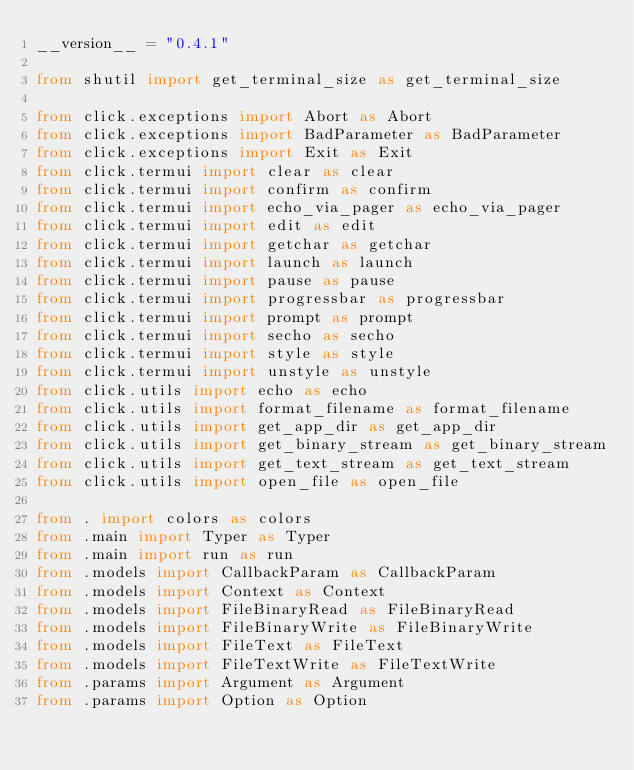Convert code to text. <code><loc_0><loc_0><loc_500><loc_500><_Python_>__version__ = "0.4.1"

from shutil import get_terminal_size as get_terminal_size

from click.exceptions import Abort as Abort
from click.exceptions import BadParameter as BadParameter
from click.exceptions import Exit as Exit
from click.termui import clear as clear
from click.termui import confirm as confirm
from click.termui import echo_via_pager as echo_via_pager
from click.termui import edit as edit
from click.termui import getchar as getchar
from click.termui import launch as launch
from click.termui import pause as pause
from click.termui import progressbar as progressbar
from click.termui import prompt as prompt
from click.termui import secho as secho
from click.termui import style as style
from click.termui import unstyle as unstyle
from click.utils import echo as echo
from click.utils import format_filename as format_filename
from click.utils import get_app_dir as get_app_dir
from click.utils import get_binary_stream as get_binary_stream
from click.utils import get_text_stream as get_text_stream
from click.utils import open_file as open_file

from . import colors as colors
from .main import Typer as Typer
from .main import run as run
from .models import CallbackParam as CallbackParam
from .models import Context as Context
from .models import FileBinaryRead as FileBinaryRead
from .models import FileBinaryWrite as FileBinaryWrite
from .models import FileText as FileText
from .models import FileTextWrite as FileTextWrite
from .params import Argument as Argument
from .params import Option as Option
</code> 